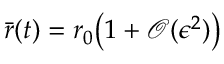<formula> <loc_0><loc_0><loc_500><loc_500>\bar { r } ( t ) = r _ { 0 } \left ( 1 + \mathcal { O } ( \epsilon ^ { 2 } ) \right )</formula> 